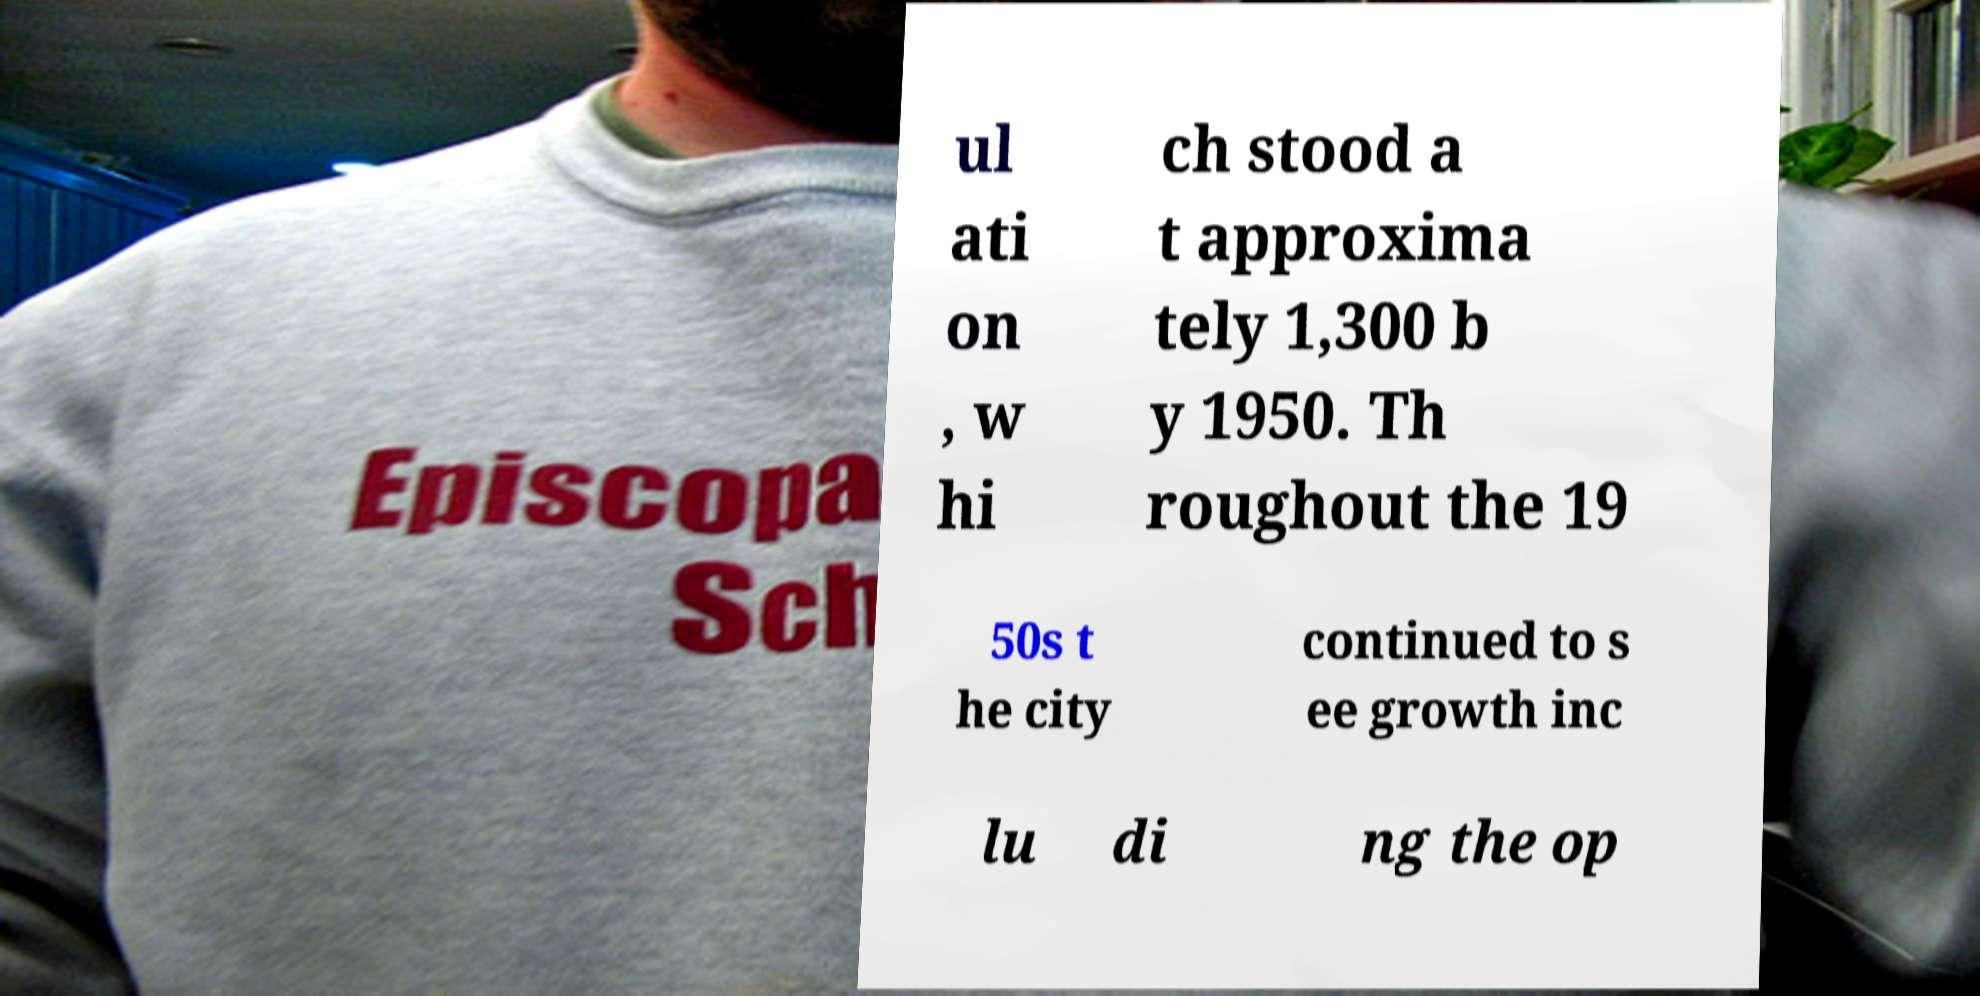Please read and relay the text visible in this image. What does it say? ul ati on , w hi ch stood a t approxima tely 1,300 b y 1950. Th roughout the 19 50s t he city continued to s ee growth inc lu di ng the op 